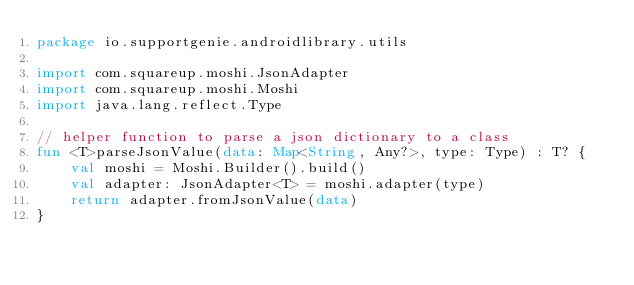<code> <loc_0><loc_0><loc_500><loc_500><_Kotlin_>package io.supportgenie.androidlibrary.utils

import com.squareup.moshi.JsonAdapter
import com.squareup.moshi.Moshi
import java.lang.reflect.Type

// helper function to parse a json dictionary to a class
fun <T>parseJsonValue(data: Map<String, Any?>, type: Type) : T? {
    val moshi = Moshi.Builder().build()
    val adapter: JsonAdapter<T> = moshi.adapter(type)
    return adapter.fromJsonValue(data)
}
</code> 